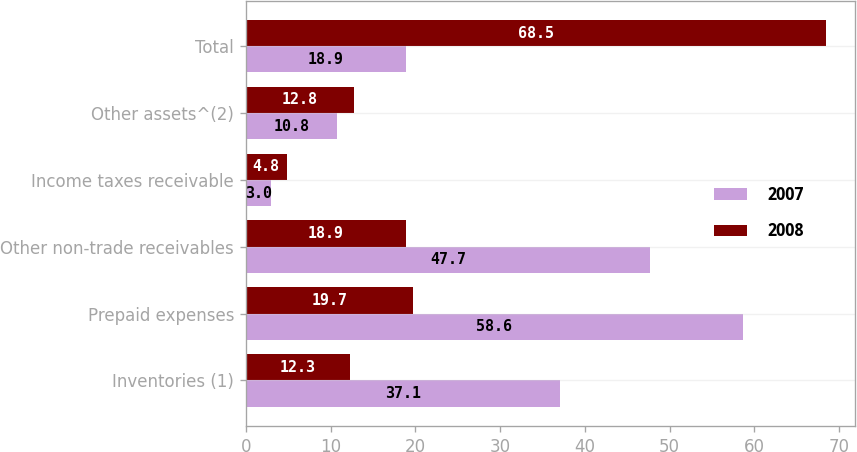Convert chart to OTSL. <chart><loc_0><loc_0><loc_500><loc_500><stacked_bar_chart><ecel><fcel>Inventories (1)<fcel>Prepaid expenses<fcel>Other non-trade receivables<fcel>Income taxes receivable<fcel>Other assets^(2)<fcel>Total<nl><fcel>2007<fcel>37.1<fcel>58.6<fcel>47.7<fcel>3<fcel>10.8<fcel>18.9<nl><fcel>2008<fcel>12.3<fcel>19.7<fcel>18.9<fcel>4.8<fcel>12.8<fcel>68.5<nl></chart> 